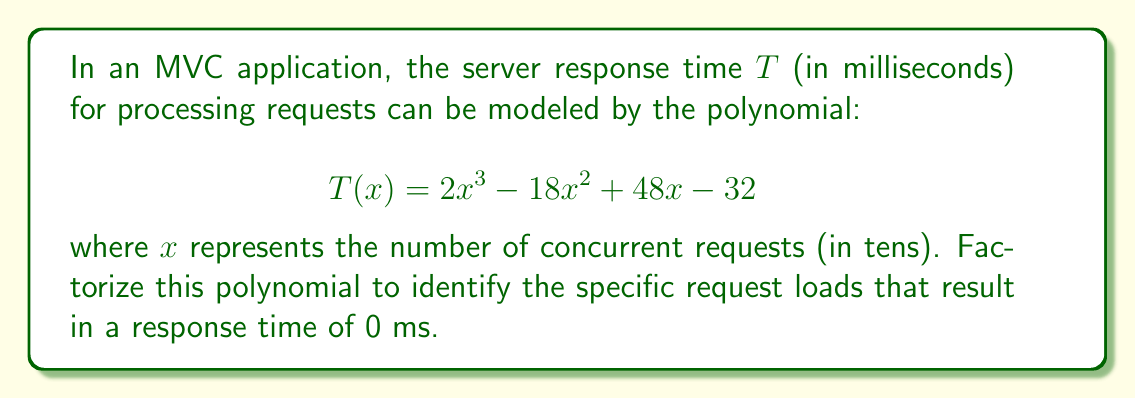Can you answer this question? To factorize this polynomial, we'll follow these steps:

1) First, let's check if there are any common factors. In this case, there are none.

2) Next, we'll try to guess one of the factors. Since the constant term is -32, potential factors could be ±1, ±2, ±4, ±8, ±16, ±32. Let's try $x = 2$:

   $T(2) = 2(2^3) - 18(2^2) + 48(2) - 32 = 16 - 72 + 96 - 32 = 8$

   $T(2) \neq 0$, so $x - 2$ is not a factor.

3) Let's try $x = 4$:

   $T(4) = 2(4^3) - 18(4^2) + 48(4) - 32 = 128 - 288 + 192 - 32 = 0$

   $T(4) = 0$, so $x - 4$ is a factor.

4) We can now divide $T(x)$ by $(x - 4)$ using polynomial long division:

   $2x^3 - 18x^2 + 48x - 32 = (x - 4)(2x^2 - 10x + 12)$

5) Now we need to factorize $2x^2 - 10x + 12$. We can do this by grouping:

   $2x^2 - 10x + 12 = 2(x^2 - 5x + 6) = 2(x - 2)(x - 3)$

6) Putting it all together:

   $T(x) = 2x^3 - 18x^2 + 48x - 32 = 2(x - 4)(x - 2)(x - 3)$

Therefore, the response time will be 0 ms when $x = 4$, $x = 2$, or $x = 3$, corresponding to 40, 20, or 30 concurrent requests respectively.
Answer: $T(x) = 2(x - 4)(x - 2)(x - 3)$ 